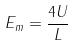Convert formula to latex. <formula><loc_0><loc_0><loc_500><loc_500>E _ { m } = \frac { 4 U } { L }</formula> 